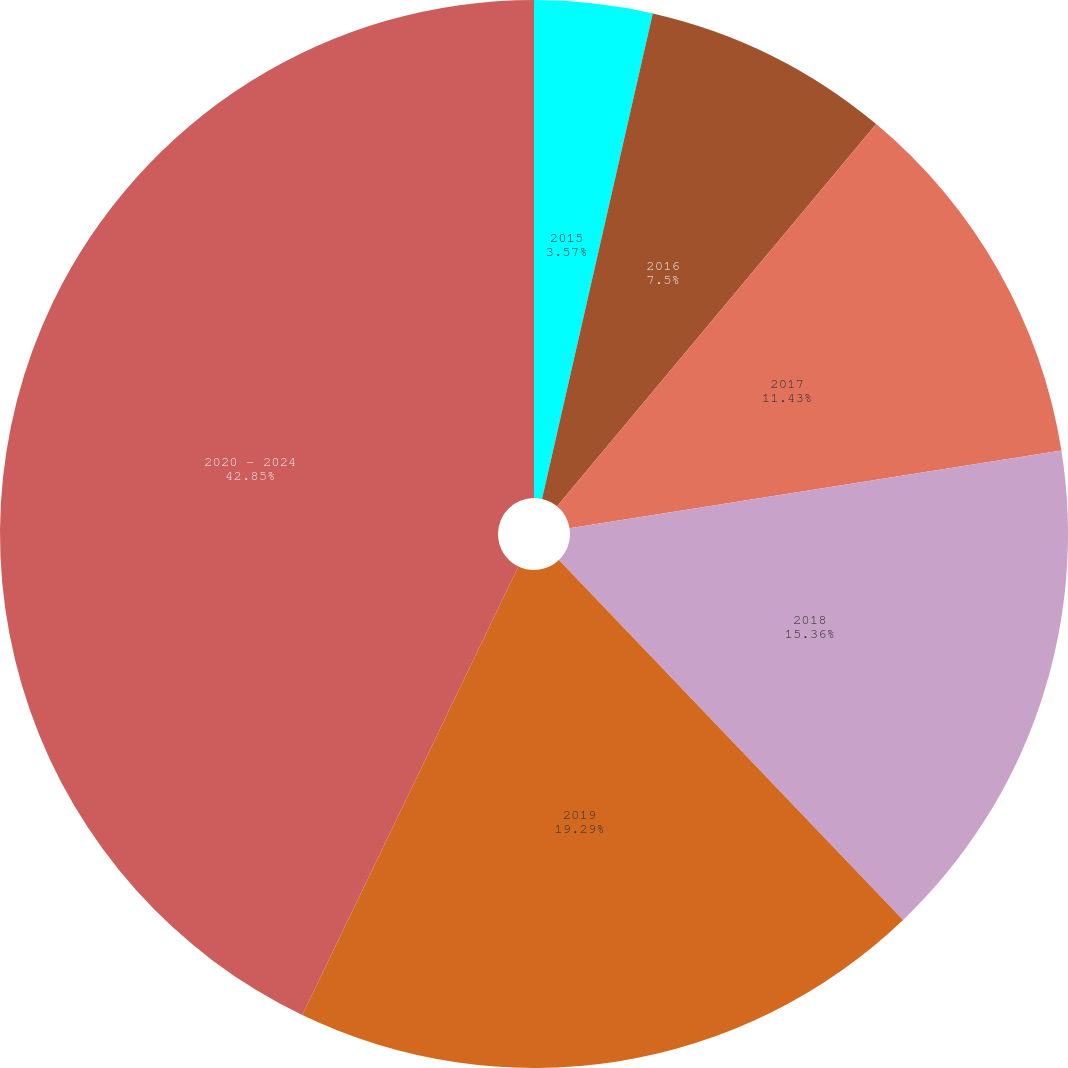Convert chart to OTSL. <chart><loc_0><loc_0><loc_500><loc_500><pie_chart><fcel>2015<fcel>2016<fcel>2017<fcel>2018<fcel>2019<fcel>2020 - 2024<nl><fcel>3.57%<fcel>7.5%<fcel>11.43%<fcel>15.36%<fcel>19.29%<fcel>42.86%<nl></chart> 